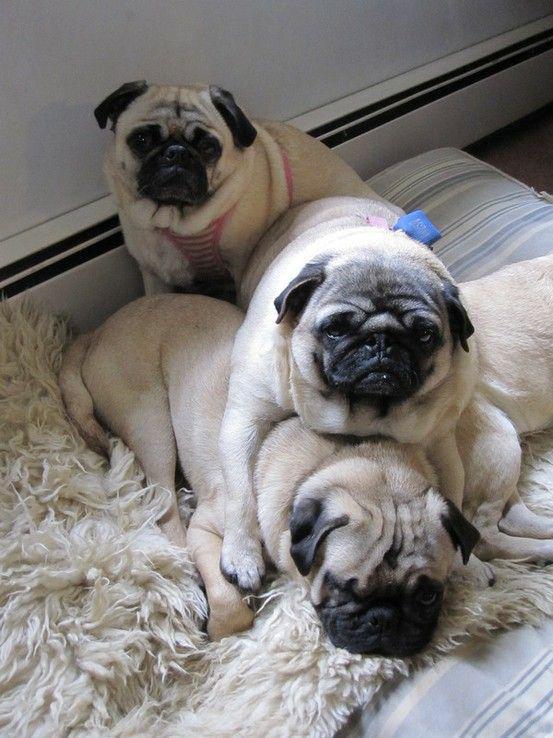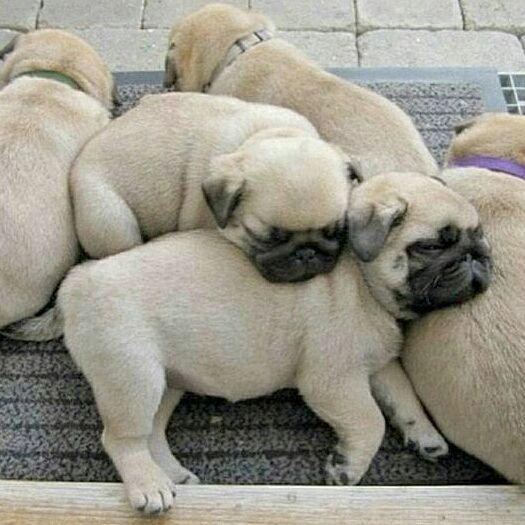The first image is the image on the left, the second image is the image on the right. Assess this claim about the two images: "Each image includes buff-beige pugs with dark muzzles, and no image contains fewer than three pugs.". Correct or not? Answer yes or no. Yes. The first image is the image on the left, the second image is the image on the right. Examine the images to the left and right. Is the description "There are more dogs in the image on the right." accurate? Answer yes or no. Yes. 